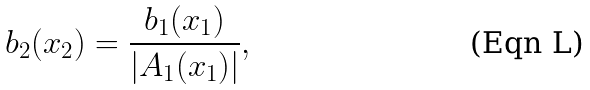Convert formula to latex. <formula><loc_0><loc_0><loc_500><loc_500>b _ { 2 } ( x _ { 2 } ) = \frac { b _ { 1 } ( x _ { 1 } ) } { | A _ { 1 } ( x _ { 1 } ) | } ,</formula> 